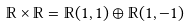Convert formula to latex. <formula><loc_0><loc_0><loc_500><loc_500>\mathbb { R } \times \mathbb { R } = \mathbb { R } ( 1 , 1 ) \oplus \mathbb { R } ( 1 , - 1 )</formula> 